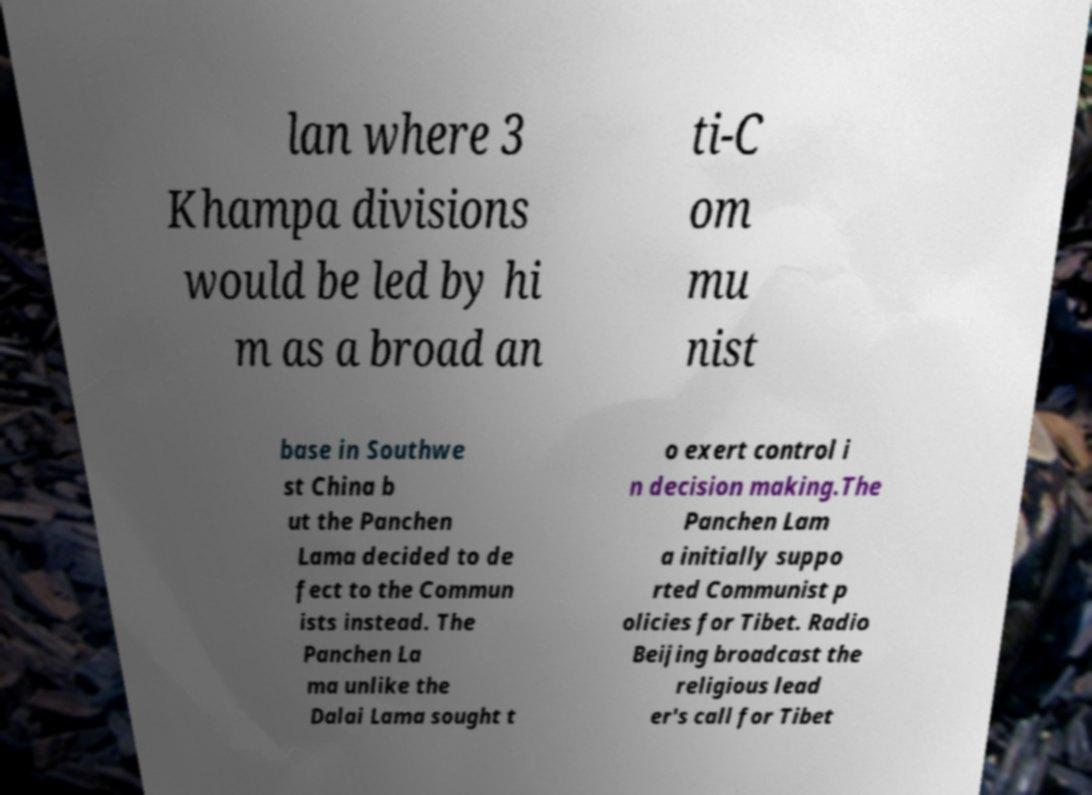What messages or text are displayed in this image? I need them in a readable, typed format. lan where 3 Khampa divisions would be led by hi m as a broad an ti-C om mu nist base in Southwe st China b ut the Panchen Lama decided to de fect to the Commun ists instead. The Panchen La ma unlike the Dalai Lama sought t o exert control i n decision making.The Panchen Lam a initially suppo rted Communist p olicies for Tibet. Radio Beijing broadcast the religious lead er's call for Tibet 